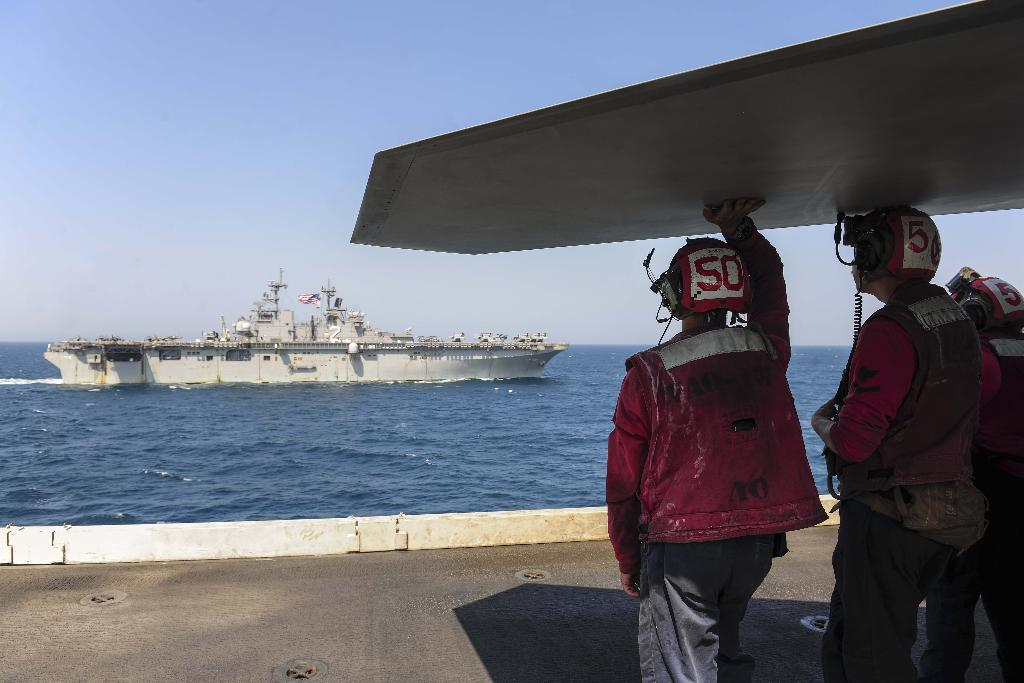<image>
Summarize the visual content of the image. A person watches a ship on the water with a 50 on the back of his helmet. 